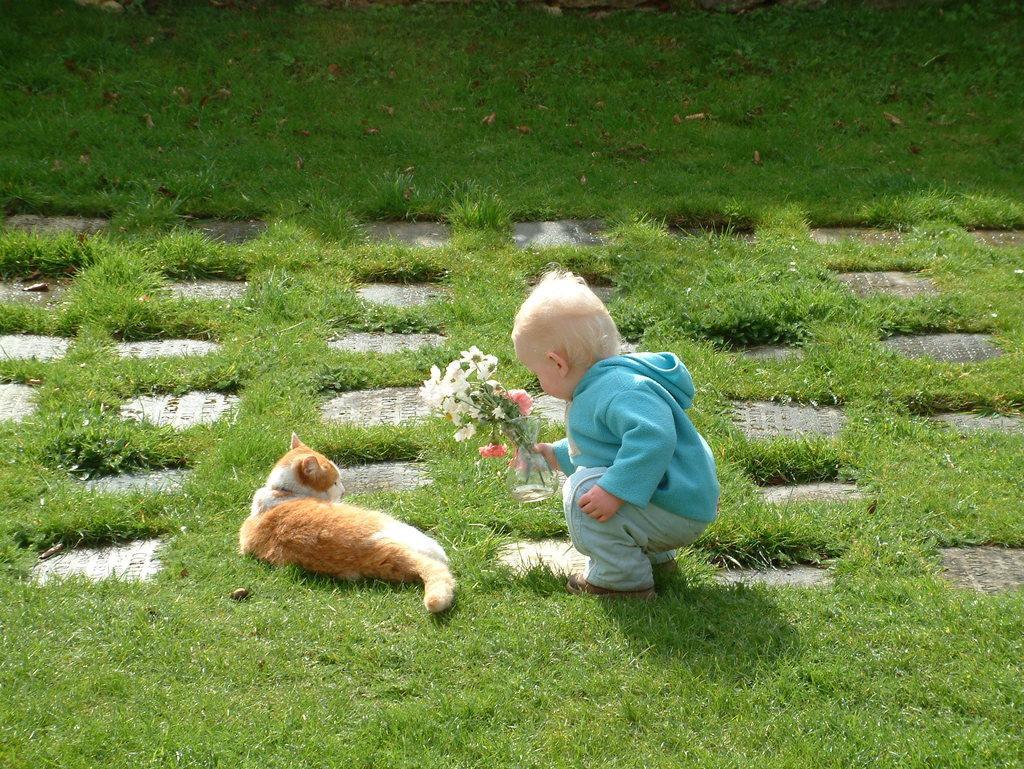Please provide a concise description of this image. In this image I can see a cat which is brown and white in color is laying on the grass and a baby wearing blue colored dress is holding few flowers which are white and pink in color. I can see some grass and few leaves on the ground. 